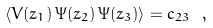Convert formula to latex. <formula><loc_0><loc_0><loc_500><loc_500>\left \langle V ( z _ { 1 } ) \, \Psi ( z _ { 2 } ) \, \Psi ( z _ { 3 } ) \right \rangle = c _ { 2 3 } \ ,</formula> 